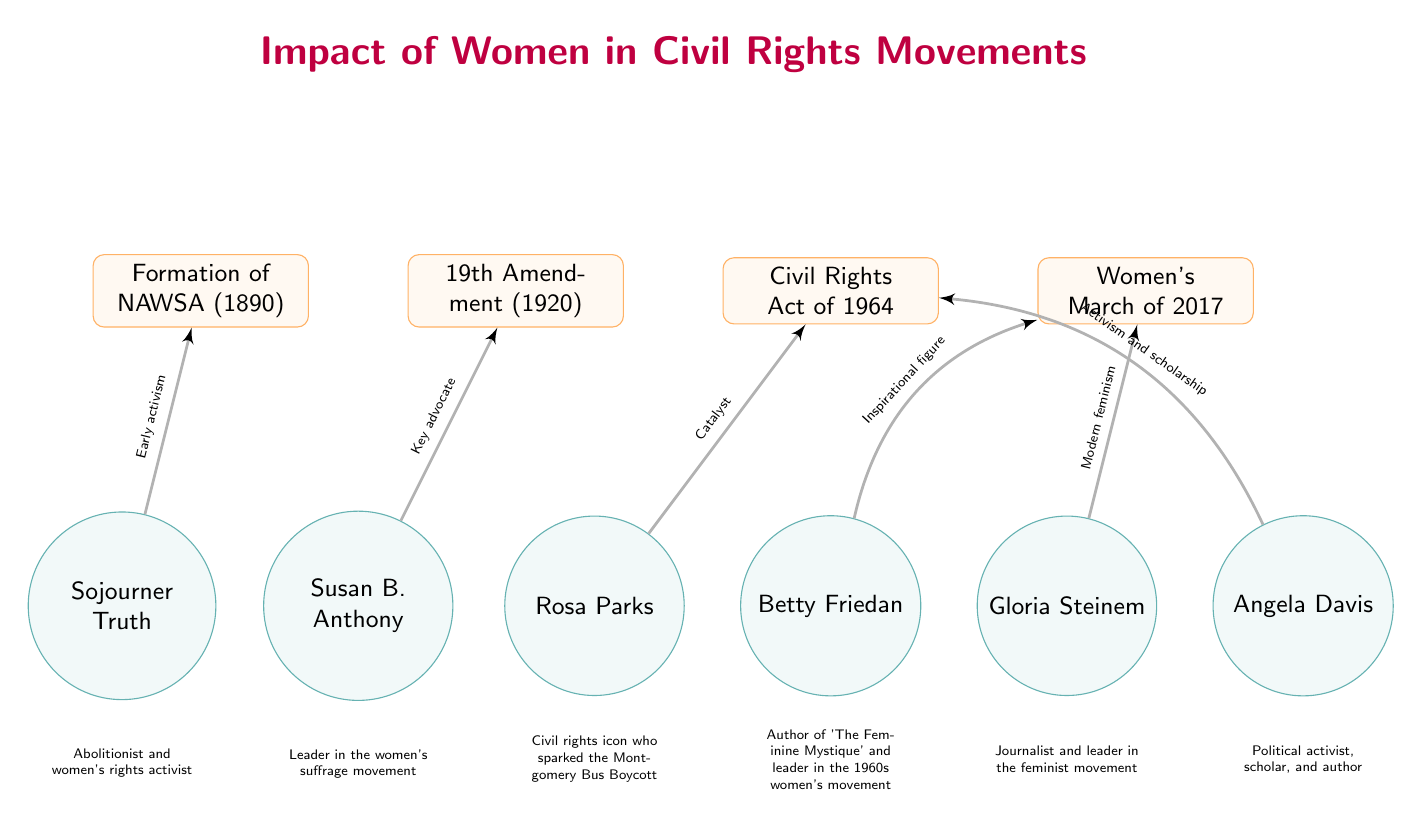What is the first event listed in the diagram? The first event, from left to right in the diagram, is the "Formation of NAWSA (1890)." This is determined by locating the event nodes, which are listed sequentially.
Answer: Formation of NAWSA (1890) Who is connected to the Civil Rights Act of 1964? The two individuals connected to the Civil Rights Act of 1964 are Rosa Parks and Angela Davis. The connections to these individuals are represented by edges leading to the event node.
Answer: Rosa Parks, Angela Davis How many notable leaders are represented in the diagram? There are six notable leaders represented in the diagram. Each leader is shown as a circular node, and counting these nodes gives the total number of notable leaders.
Answer: 6 Which amendment is associated with Susan B. Anthony? The amendment associated with Susan B. Anthony is the "19th Amendment (1920)." This is confirmed by following the edge from Susan B. Anthony to the corresponding event node in the diagram.
Answer: 19th Amendment (1920) What role does Betty Friedan play in the Women's March of 2017? Betty Friedan is labeled as an "Inspirational figure" connected to the Women's March of 2017. This relationship is indicated by the edge linking her to the event node with that specific label.
Answer: Inspirational figure Which civil rights leader is known for their role as a catalyst? Rosa Parks is known for her role as a "Catalyst" in relation to the Civil Rights Act of 1964, as indicated by the edge description leading from her to that event node.
Answer: Rosa Parks What is the connection between Gloria Steinem and the Women's March of 2017? Gloria Steinem is connected to the Women's March of 2017 through the label "Modern feminism," which describes her influence on this event, as shown by the edge leading to the event node.
Answer: Modern feminism How did Sojourner Truth contribute to the civil rights movements? Sojourner Truth contributed as an "Early activist," which is noted in the connection leading from her to the Formation of NAWSA event.
Answer: Early activist 